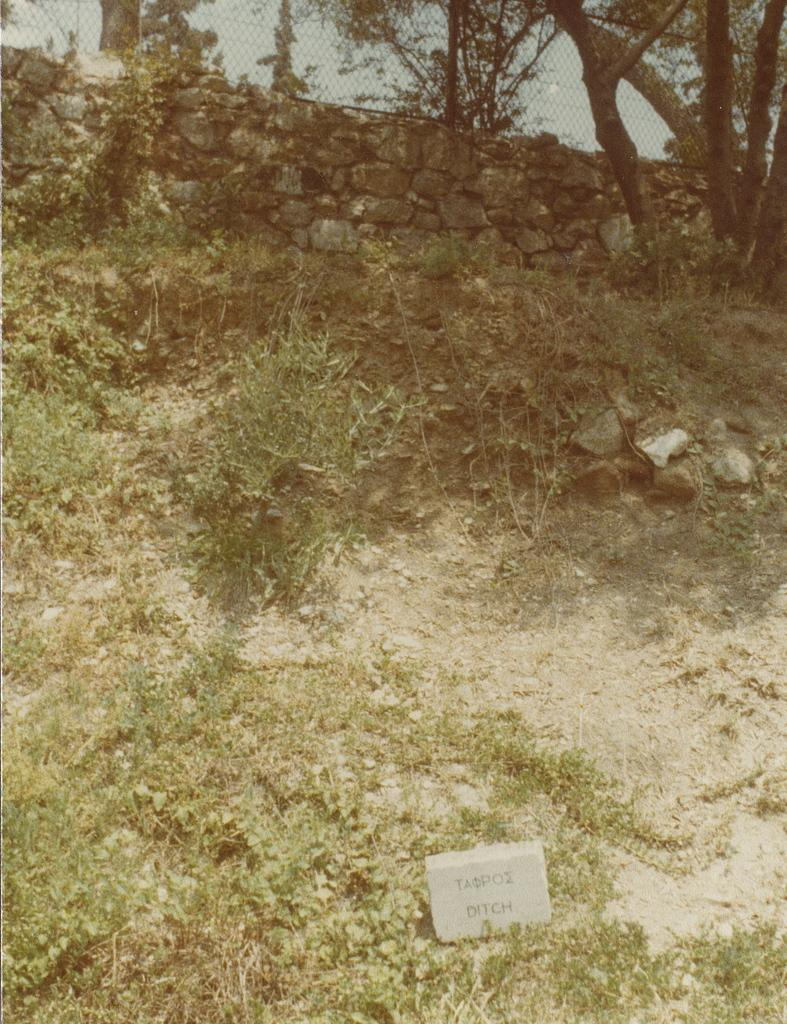What type of vegetation can be seen in the image? There is grass and bushes in the image. What type of structure is present in the image? There is a rock wall in the image. Can you describe the tree in the image? There is a tree beside the rock wall in the image. What is covering the rock wall in the image? There is a mesh above the rock wall in the image. How many jellyfish can be seen swimming in the image? There are no jellyfish present in the image; it features grass, bushes, a rock wall, a tree, and a mesh. What type of competition is taking place in the image? There is no competition present in the image. 